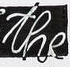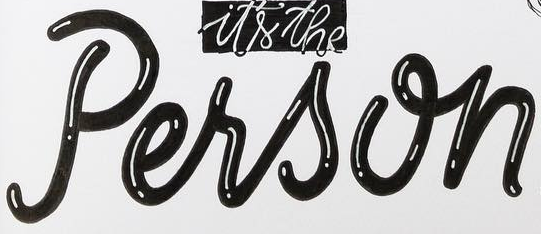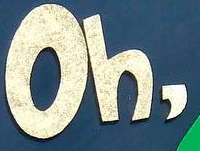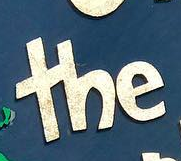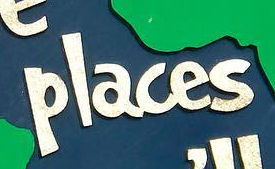What words can you see in these images in sequence, separated by a semicolon? the; Person; Oh,; the; places 